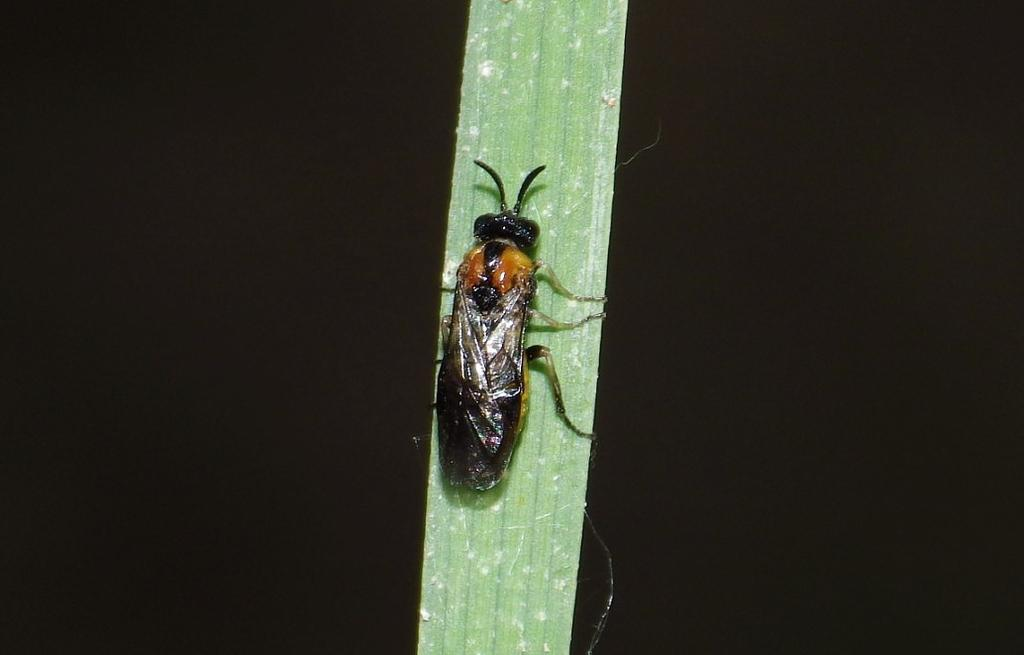What is the main subject of the image? There is a cockroach in the image. What is the cockroach doing in the image? The cockroach is climbing a stem. What type of pump can be seen in the image? There is no pump present in the image; it features a cockroach climbing a stem. Is the snake visible in the image? There is no snake present in the image. 